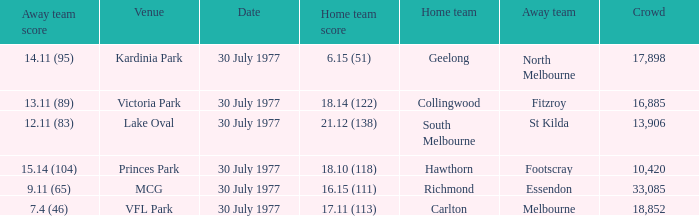Whom is the home team when the away team score is 9.11 (65)? Richmond. 